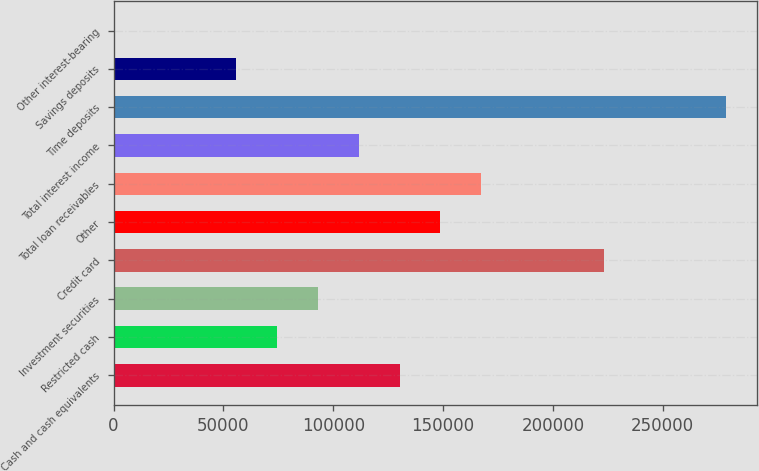Convert chart to OTSL. <chart><loc_0><loc_0><loc_500><loc_500><bar_chart><fcel>Cash and cash equivalents<fcel>Restricted cash<fcel>Investment securities<fcel>Credit card<fcel>Other<fcel>Total loan receivables<fcel>Total interest income<fcel>Time deposits<fcel>Savings deposits<fcel>Other interest-bearing<nl><fcel>130223<fcel>74443.4<fcel>93036.5<fcel>223188<fcel>148816<fcel>167409<fcel>111630<fcel>278968<fcel>55850.3<fcel>71<nl></chart> 